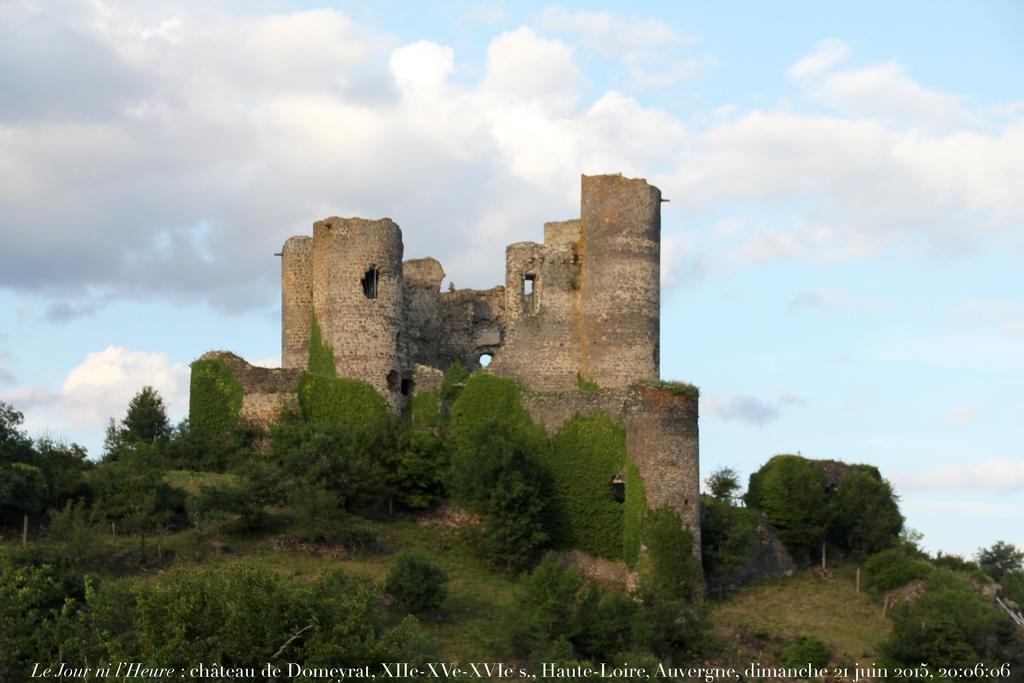What type of natural vegetation is present in the image? There are many trees in the image. What type of structure can be seen in the image? There is a fort in the image. What can be seen in the background of the image? There are clouds visible in the background of the image. What part of the natural environment is visible in the image? The sky is visible in the background of the image. What type of society is depicted in the image? There is no depiction of a society in the image; it features trees and a fort. Who is the writer in the image? There is no writer present in the image. 